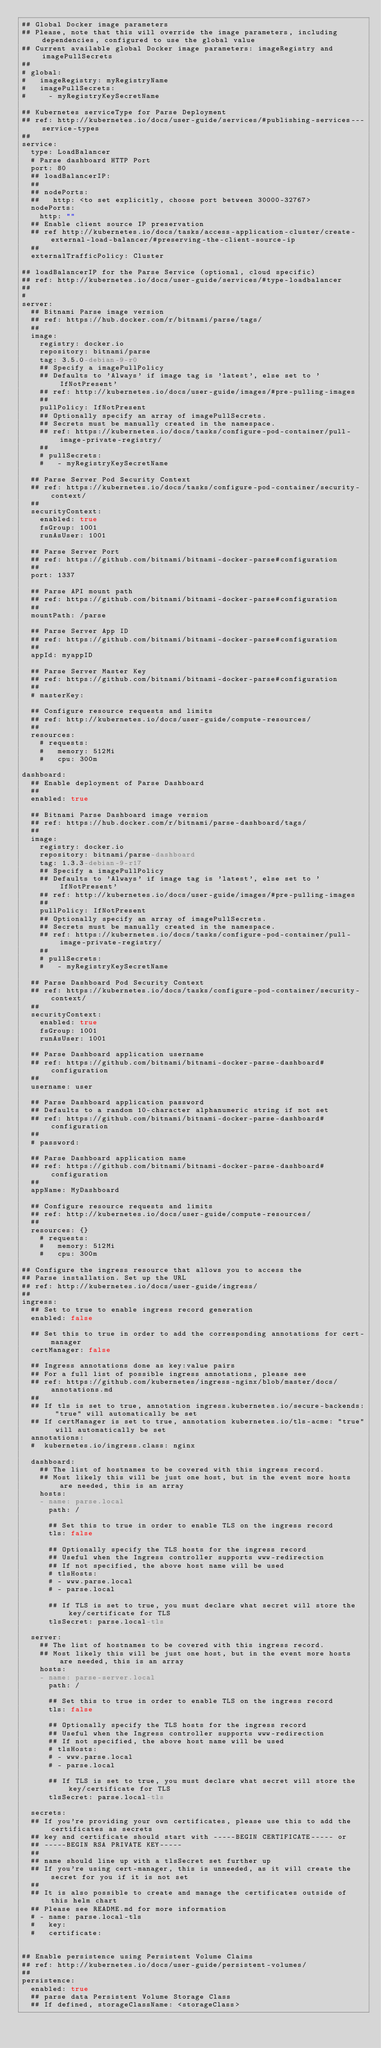Convert code to text. <code><loc_0><loc_0><loc_500><loc_500><_YAML_>## Global Docker image parameters
## Please, note that this will override the image parameters, including dependencies, configured to use the global value
## Current available global Docker image parameters: imageRegistry and imagePullSecrets
##
# global:
#   imageRegistry: myRegistryName
#   imagePullSecrets:
#     - myRegistryKeySecretName

## Kubernetes serviceType for Parse Deployment
## ref: http://kubernetes.io/docs/user-guide/services/#publishing-services---service-types
##
service:
  type: LoadBalancer
  # Parse dashboard HTTP Port
  port: 80
  ## loadBalancerIP:
  ##
  ## nodePorts:
  ##   http: <to set explicitly, choose port between 30000-32767>
  nodePorts:
    http: ""
  ## Enable client source IP preservation
  ## ref http://kubernetes.io/docs/tasks/access-application-cluster/create-external-load-balancer/#preserving-the-client-source-ip
  ##
  externalTrafficPolicy: Cluster

## loadBalancerIP for the Parse Service (optional, cloud specific)
## ref: http://kubernetes.io/docs/user-guide/services/#type-loadbalancer
##
#
server:
  ## Bitnami Parse image version
  ## ref: https://hub.docker.com/r/bitnami/parse/tags/
  ##
  image:
    registry: docker.io
    repository: bitnami/parse
    tag: 3.5.0-debian-9-r0
    ## Specify a imagePullPolicy
    ## Defaults to 'Always' if image tag is 'latest', else set to 'IfNotPresent'
    ## ref: http://kubernetes.io/docs/user-guide/images/#pre-pulling-images
    ##
    pullPolicy: IfNotPresent
    ## Optionally specify an array of imagePullSecrets.
    ## Secrets must be manually created in the namespace.
    ## ref: https://kubernetes.io/docs/tasks/configure-pod-container/pull-image-private-registry/
    ##
    # pullSecrets:
    #   - myRegistryKeySecretName

  ## Parse Server Pod Security Context
  ## ref: https://kubernetes.io/docs/tasks/configure-pod-container/security-context/
  ##
  securityContext:
    enabled: true
    fsGroup: 1001
    runAsUser: 1001

  ## Parse Server Port
  ## ref: https://github.com/bitnami/bitnami-docker-parse#configuration
  ##
  port: 1337

  ## Parse API mount path
  ## ref: https://github.com/bitnami/bitnami-docker-parse#configuration
  ##
  mountPath: /parse

  ## Parse Server App ID
  ## ref: https://github.com/bitnami/bitnami-docker-parse#configuration
  ##
  appId: myappID

  ## Parse Server Master Key
  ## ref: https://github.com/bitnami/bitnami-docker-parse#configuration
  ##
  # masterKey:

  ## Configure resource requests and limits
  ## ref: http://kubernetes.io/docs/user-guide/compute-resources/
  ##
  resources:
    # requests:
    #   memory: 512Mi
    #   cpu: 300m

dashboard:
  ## Enable deployment of Parse Dashboard
  ##
  enabled: true

  ## Bitnami Parse Dashboard image version
  ## ref: https://hub.docker.com/r/bitnami/parse-dashboard/tags/
  ##
  image:
    registry: docker.io
    repository: bitnami/parse-dashboard
    tag: 1.3.3-debian-9-r17
    ## Specify a imagePullPolicy
    ## Defaults to 'Always' if image tag is 'latest', else set to 'IfNotPresent'
    ## ref: http://kubernetes.io/docs/user-guide/images/#pre-pulling-images
    ##
    pullPolicy: IfNotPresent
    ## Optionally specify an array of imagePullSecrets.
    ## Secrets must be manually created in the namespace.
    ## ref: https://kubernetes.io/docs/tasks/configure-pod-container/pull-image-private-registry/
    ##
    # pullSecrets:
    #   - myRegistryKeySecretName

  ## Parse Dashboard Pod Security Context
  ## ref: https://kubernetes.io/docs/tasks/configure-pod-container/security-context/
  ##
  securityContext:
    enabled: true
    fsGroup: 1001
    runAsUser: 1001

  ## Parse Dashboard application username
  ## ref: https://github.com/bitnami/bitnami-docker-parse-dashboard#configuration
  ##
  username: user

  ## Parse Dashboard application password
  ## Defaults to a random 10-character alphanumeric string if not set
  ## ref: https://github.com/bitnami/bitnami-docker-parse-dashboard#configuration
  ##
  # password:

  ## Parse Dashboard application name
  ## ref: https://github.com/bitnami/bitnami-docker-parse-dashboard#configuration
  ##
  appName: MyDashboard

  ## Configure resource requests and limits
  ## ref: http://kubernetes.io/docs/user-guide/compute-resources/
  ##
  resources: {}
    # requests:
    #   memory: 512Mi
    #   cpu: 300m

## Configure the ingress resource that allows you to access the
## Parse installation. Set up the URL
## ref: http://kubernetes.io/docs/user-guide/ingress/
##
ingress:
  ## Set to true to enable ingress record generation
  enabled: false

  ## Set this to true in order to add the corresponding annotations for cert-manager
  certManager: false

  ## Ingress annotations done as key:value pairs
  ## For a full list of possible ingress annotations, please see
  ## ref: https://github.com/kubernetes/ingress-nginx/blob/master/docs/annotations.md
  ##
  ## If tls is set to true, annotation ingress.kubernetes.io/secure-backends: "true" will automatically be set
  ## If certManager is set to true, annotation kubernetes.io/tls-acme: "true" will automatically be set
  annotations:
  #  kubernetes.io/ingress.class: nginx

  dashboard:
    ## The list of hostnames to be covered with this ingress record.
    ## Most likely this will be just one host, but in the event more hosts are needed, this is an array
    hosts:
    - name: parse.local
      path: /

      ## Set this to true in order to enable TLS on the ingress record
      tls: false

      ## Optionally specify the TLS hosts for the ingress record
      ## Useful when the Ingress controller supports www-redirection
      ## If not specified, the above host name will be used
      # tlsHosts:
      # - www.parse.local
      # - parse.local

      ## If TLS is set to true, you must declare what secret will store the key/certificate for TLS
      tlsSecret: parse.local-tls

  server:
    ## The list of hostnames to be covered with this ingress record.
    ## Most likely this will be just one host, but in the event more hosts are needed, this is an array
    hosts:
    - name: parse-server.local
      path: /

      ## Set this to true in order to enable TLS on the ingress record
      tls: false

      ## Optionally specify the TLS hosts for the ingress record
      ## Useful when the Ingress controller supports www-redirection
      ## If not specified, the above host name will be used
      # tlsHosts:
      # - www.parse.local
      # - parse.local

      ## If TLS is set to true, you must declare what secret will store the key/certificate for TLS
      tlsSecret: parse.local-tls

  secrets:
  ## If you're providing your own certificates, please use this to add the certificates as secrets
  ## key and certificate should start with -----BEGIN CERTIFICATE----- or
  ## -----BEGIN RSA PRIVATE KEY-----
  ##
  ## name should line up with a tlsSecret set further up
  ## If you're using cert-manager, this is unneeded, as it will create the secret for you if it is not set
  ##
  ## It is also possible to create and manage the certificates outside of this helm chart
  ## Please see README.md for more information
  # - name: parse.local-tls
  #   key:
  #   certificate:


## Enable persistence using Persistent Volume Claims
## ref: http://kubernetes.io/docs/user-guide/persistent-volumes/
##
persistence:
  enabled: true
  ## parse data Persistent Volume Storage Class
  ## If defined, storageClassName: <storageClass></code> 